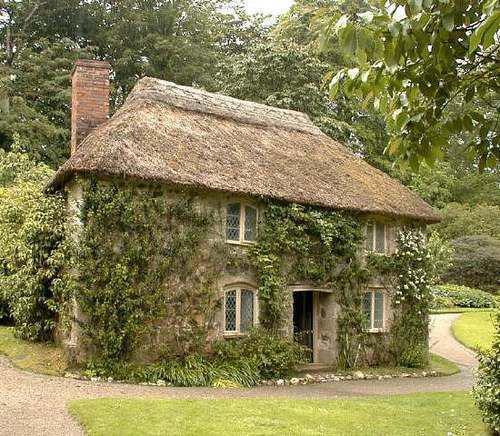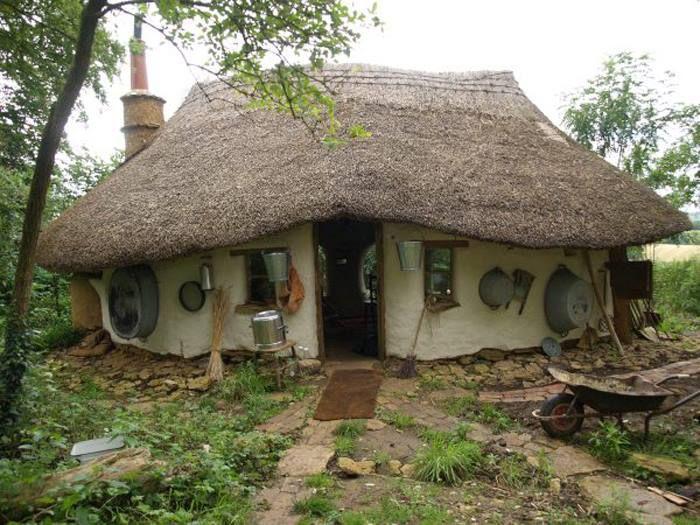The first image is the image on the left, the second image is the image on the right. Assess this claim about the two images: "On image shows stairs ascending rightward to a deck on an elevated structure with a peaked pyramid-shaped roof.". Correct or not? Answer yes or no. No. The first image is the image on the left, the second image is the image on the right. Examine the images to the left and right. Is the description "An outdoor ladder leads up to a structure in one of the images." accurate? Answer yes or no. No. 